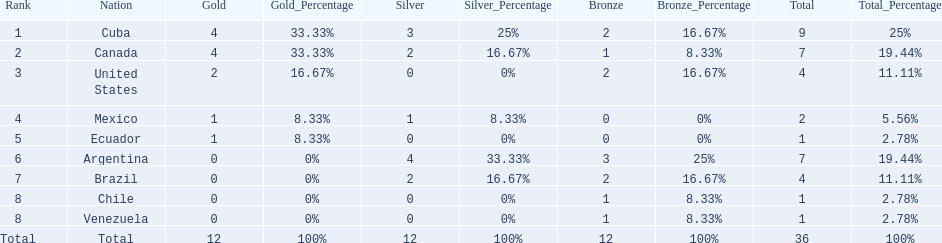How many total medals did argentina win? 7. 